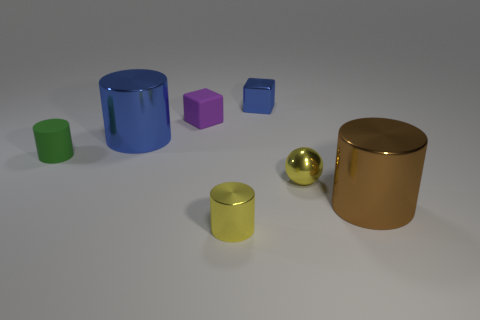Is the number of tiny green objects that are in front of the tiny metallic sphere the same as the number of blue cylinders that are on the right side of the big brown cylinder?
Provide a short and direct response. Yes. There is a big metallic thing that is on the left side of the metallic thing on the right side of the tiny shiny sphere; what is its shape?
Provide a short and direct response. Cylinder. What is the material of the other big thing that is the same shape as the large blue metallic object?
Make the answer very short. Metal. What is the color of the rubber cylinder that is the same size as the yellow metallic ball?
Provide a succinct answer. Green. Are there the same number of tiny yellow spheres in front of the yellow sphere and spheres?
Provide a short and direct response. No. The tiny cylinder behind the brown shiny thing to the right of the small blue metal block is what color?
Provide a short and direct response. Green. What is the size of the blue metallic thing left of the matte object behind the green cylinder?
Your answer should be compact. Large. What size is the metallic sphere that is the same color as the tiny shiny cylinder?
Your answer should be very brief. Small. What number of other objects are there of the same size as the yellow metal cylinder?
Offer a very short reply. 4. There is a small metallic cube on the left side of the small yellow metal object that is right of the blue object that is behind the large blue thing; what is its color?
Ensure brevity in your answer.  Blue. 